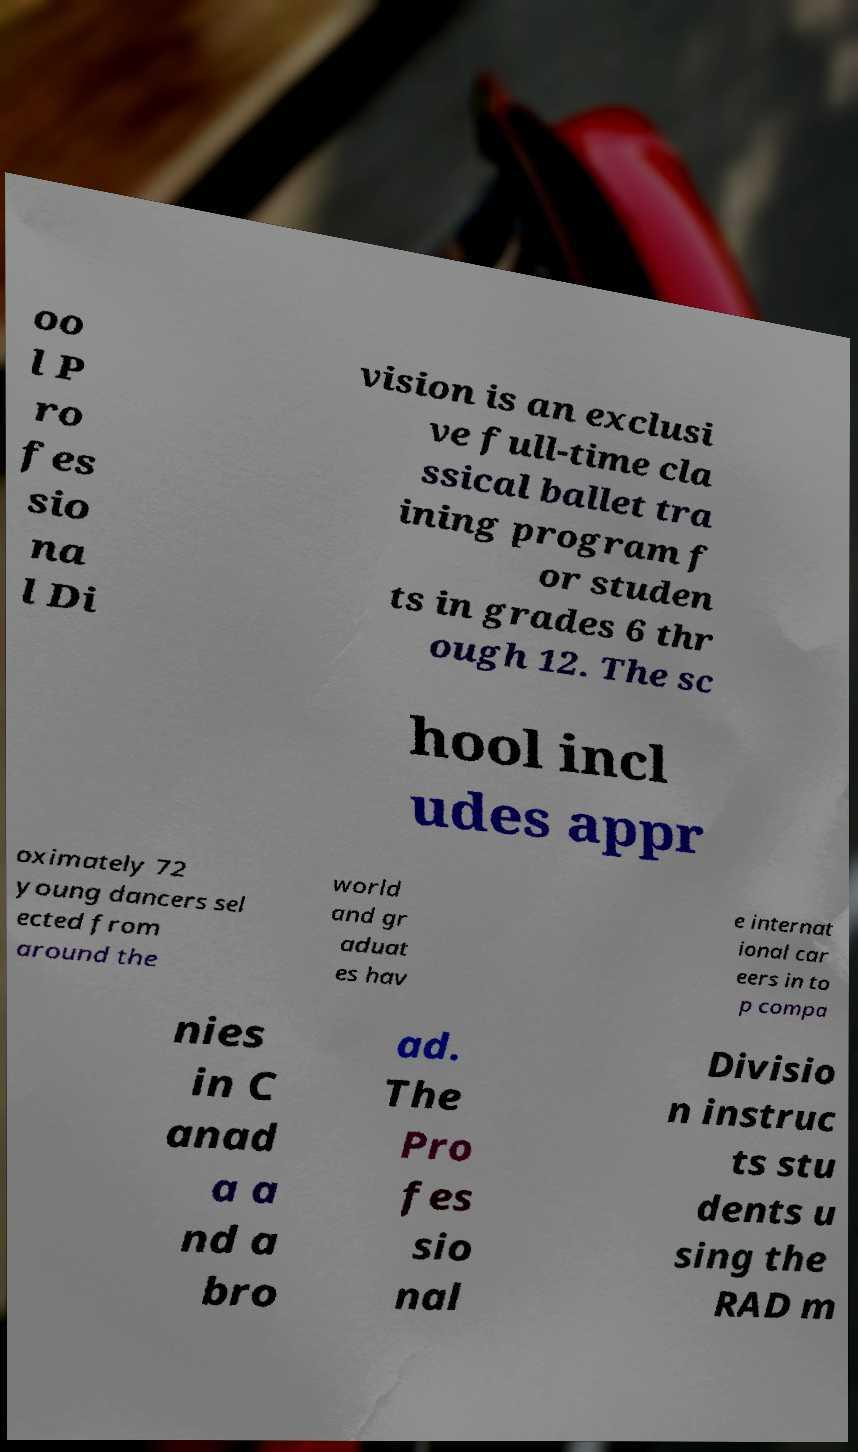What messages or text are displayed in this image? I need them in a readable, typed format. oo l P ro fes sio na l Di vision is an exclusi ve full-time cla ssical ballet tra ining program f or studen ts in grades 6 thr ough 12. The sc hool incl udes appr oximately 72 young dancers sel ected from around the world and gr aduat es hav e internat ional car eers in to p compa nies in C anad a a nd a bro ad. The Pro fes sio nal Divisio n instruc ts stu dents u sing the RAD m 